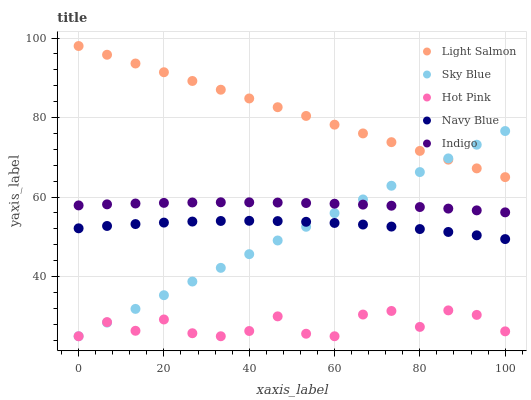Does Hot Pink have the minimum area under the curve?
Answer yes or no. Yes. Does Light Salmon have the maximum area under the curve?
Answer yes or no. Yes. Does Light Salmon have the minimum area under the curve?
Answer yes or no. No. Does Hot Pink have the maximum area under the curve?
Answer yes or no. No. Is Sky Blue the smoothest?
Answer yes or no. Yes. Is Hot Pink the roughest?
Answer yes or no. Yes. Is Light Salmon the smoothest?
Answer yes or no. No. Is Light Salmon the roughest?
Answer yes or no. No. Does Sky Blue have the lowest value?
Answer yes or no. Yes. Does Light Salmon have the lowest value?
Answer yes or no. No. Does Light Salmon have the highest value?
Answer yes or no. Yes. Does Hot Pink have the highest value?
Answer yes or no. No. Is Navy Blue less than Light Salmon?
Answer yes or no. Yes. Is Light Salmon greater than Navy Blue?
Answer yes or no. Yes. Does Sky Blue intersect Navy Blue?
Answer yes or no. Yes. Is Sky Blue less than Navy Blue?
Answer yes or no. No. Is Sky Blue greater than Navy Blue?
Answer yes or no. No. Does Navy Blue intersect Light Salmon?
Answer yes or no. No. 